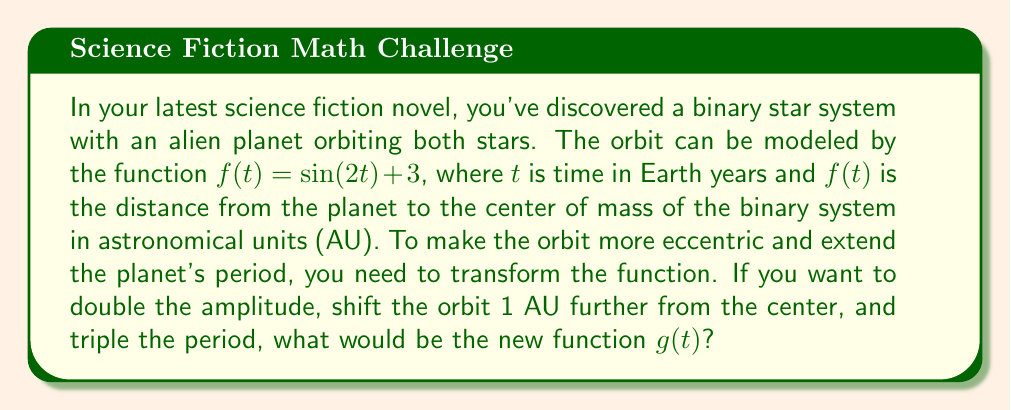Could you help me with this problem? Let's approach this step-by-step:

1) The original function is $f(t) = \sin(2t) + 3$

2) To double the amplitude, we multiply the sine term by 2:
   $2\sin(2t) + 3$

3) To shift the orbit 1 AU further from the center, we add 1 to the constant term:
   $2\sin(2t) + 4$

4) To triple the period, we need to divide the argument of sine by 3:
   $2\sin(\frac{2t}{3}) + 4$

5) Therefore, the new function $g(t)$ that satisfies all these transformations is:
   $g(t) = 2\sin(\frac{2t}{3}) + 4$

This new function $g(t)$ has twice the amplitude of $f(t)$, is shifted 1 AU further from the center, and has a period three times that of $f(t)$.
Answer: $g(t) = 2\sin(\frac{2t}{3}) + 4$ 